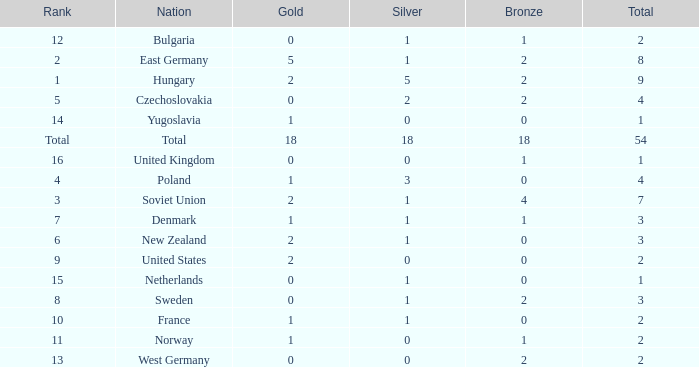What is the lowest total for those receiving less than 18 but more than 14? 1.0. Could you help me parse every detail presented in this table? {'header': ['Rank', 'Nation', 'Gold', 'Silver', 'Bronze', 'Total'], 'rows': [['12', 'Bulgaria', '0', '1', '1', '2'], ['2', 'East Germany', '5', '1', '2', '8'], ['1', 'Hungary', '2', '5', '2', '9'], ['5', 'Czechoslovakia', '0', '2', '2', '4'], ['14', 'Yugoslavia', '1', '0', '0', '1'], ['Total', 'Total', '18', '18', '18', '54'], ['16', 'United Kingdom', '0', '0', '1', '1'], ['4', 'Poland', '1', '3', '0', '4'], ['3', 'Soviet Union', '2', '1', '4', '7'], ['7', 'Denmark', '1', '1', '1', '3'], ['6', 'New Zealand', '2', '1', '0', '3'], ['9', 'United States', '2', '0', '0', '2'], ['15', 'Netherlands', '0', '1', '0', '1'], ['8', 'Sweden', '0', '1', '2', '3'], ['10', 'France', '1', '1', '0', '2'], ['11', 'Norway', '1', '0', '1', '2'], ['13', 'West Germany', '0', '0', '2', '2']]} 